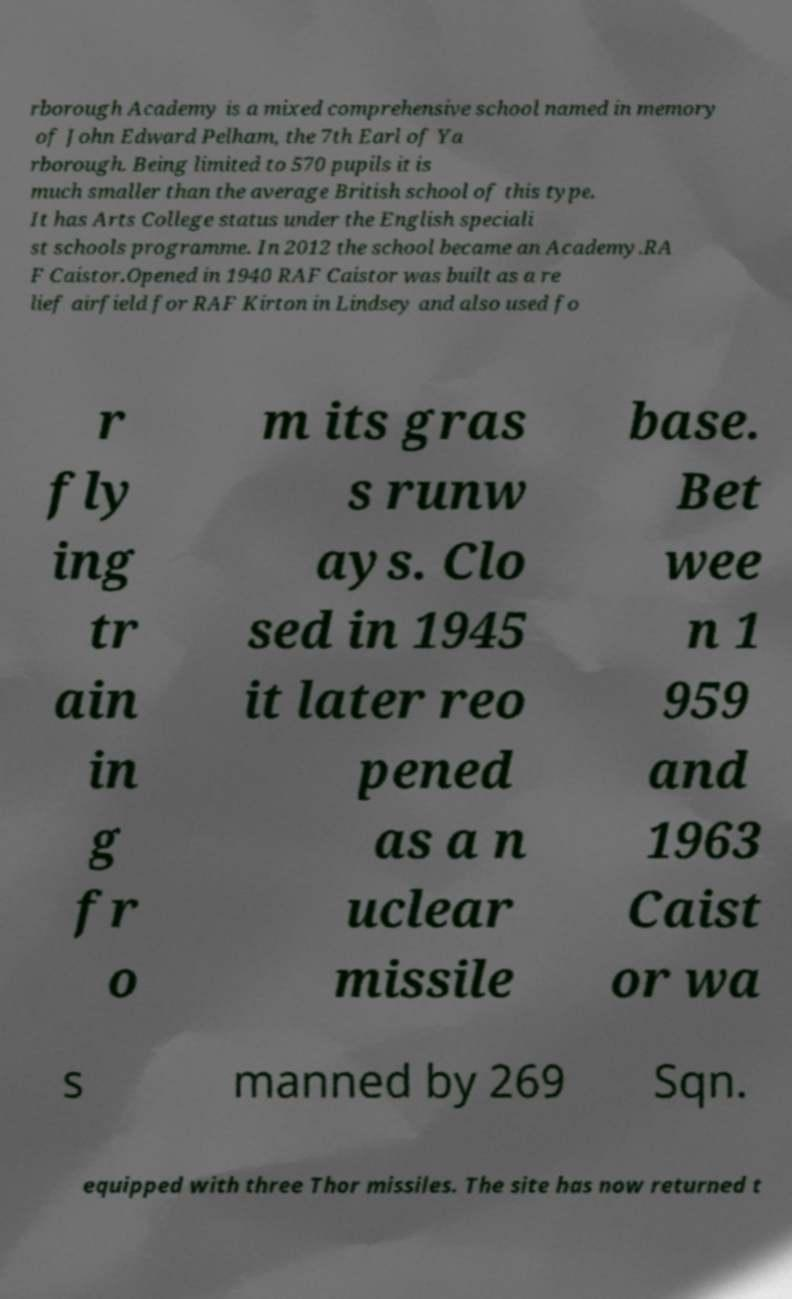For documentation purposes, I need the text within this image transcribed. Could you provide that? rborough Academy is a mixed comprehensive school named in memory of John Edward Pelham, the 7th Earl of Ya rborough. Being limited to 570 pupils it is much smaller than the average British school of this type. It has Arts College status under the English speciali st schools programme. In 2012 the school became an Academy.RA F Caistor.Opened in 1940 RAF Caistor was built as a re lief airfield for RAF Kirton in Lindsey and also used fo r fly ing tr ain in g fr o m its gras s runw ays. Clo sed in 1945 it later reo pened as a n uclear missile base. Bet wee n 1 959 and 1963 Caist or wa s manned by 269 Sqn. equipped with three Thor missiles. The site has now returned t 